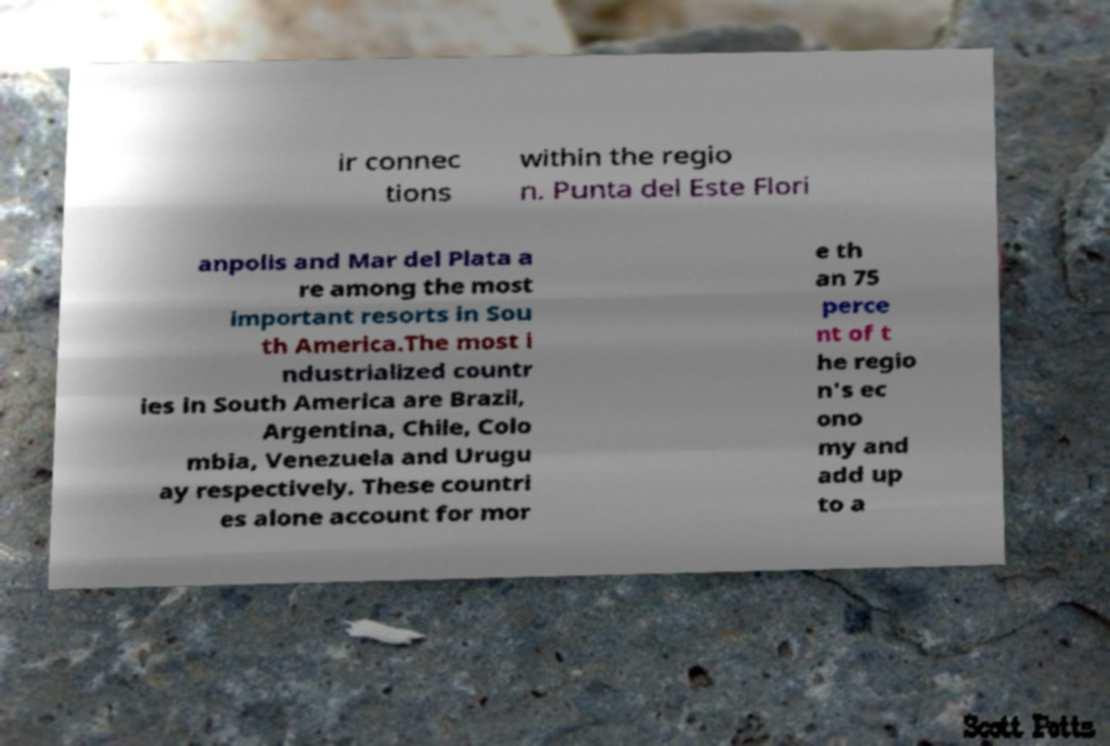Can you accurately transcribe the text from the provided image for me? ir connec tions within the regio n. Punta del Este Flori anpolis and Mar del Plata a re among the most important resorts in Sou th America.The most i ndustrialized countr ies in South America are Brazil, Argentina, Chile, Colo mbia, Venezuela and Urugu ay respectively. These countri es alone account for mor e th an 75 perce nt of t he regio n's ec ono my and add up to a 